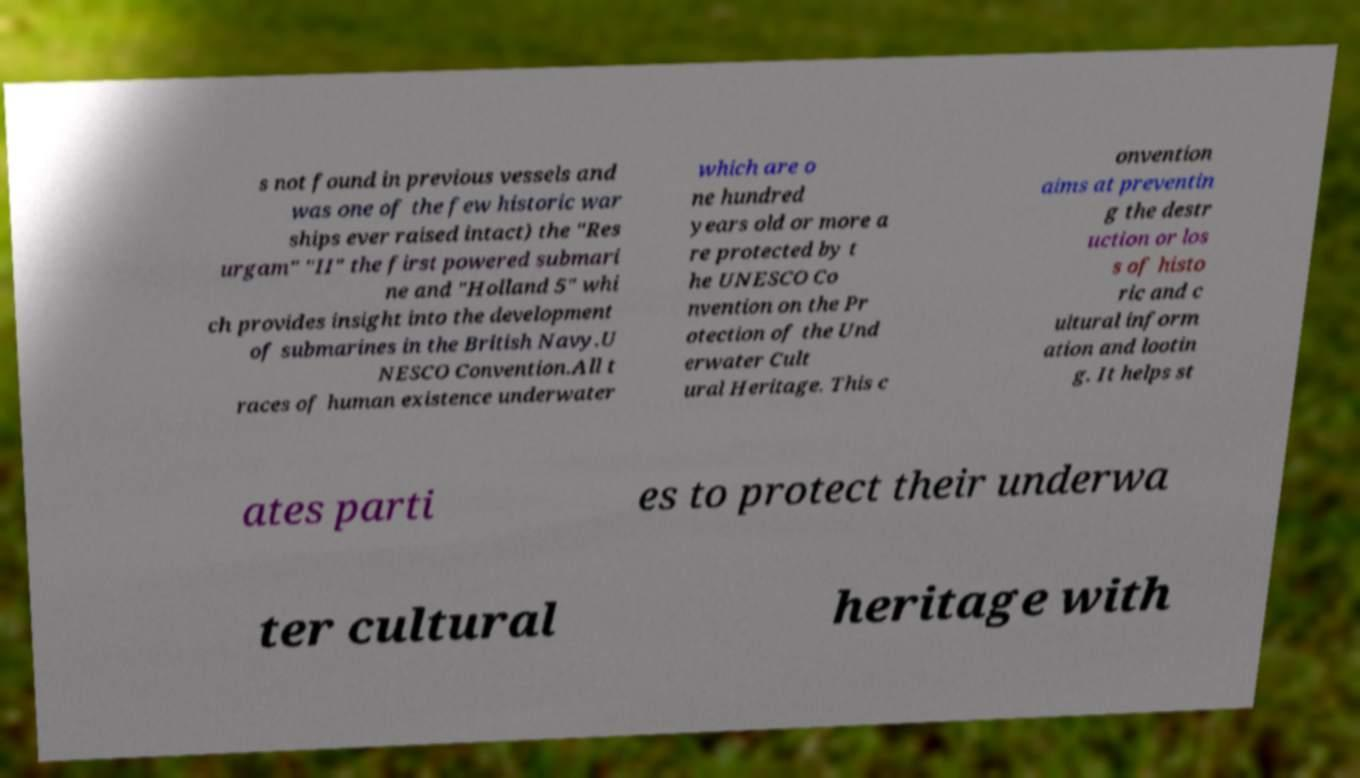For documentation purposes, I need the text within this image transcribed. Could you provide that? s not found in previous vessels and was one of the few historic war ships ever raised intact) the "Res urgam" "II" the first powered submari ne and "Holland 5" whi ch provides insight into the development of submarines in the British Navy.U NESCO Convention.All t races of human existence underwater which are o ne hundred years old or more a re protected by t he UNESCO Co nvention on the Pr otection of the Und erwater Cult ural Heritage. This c onvention aims at preventin g the destr uction or los s of histo ric and c ultural inform ation and lootin g. It helps st ates parti es to protect their underwa ter cultural heritage with 